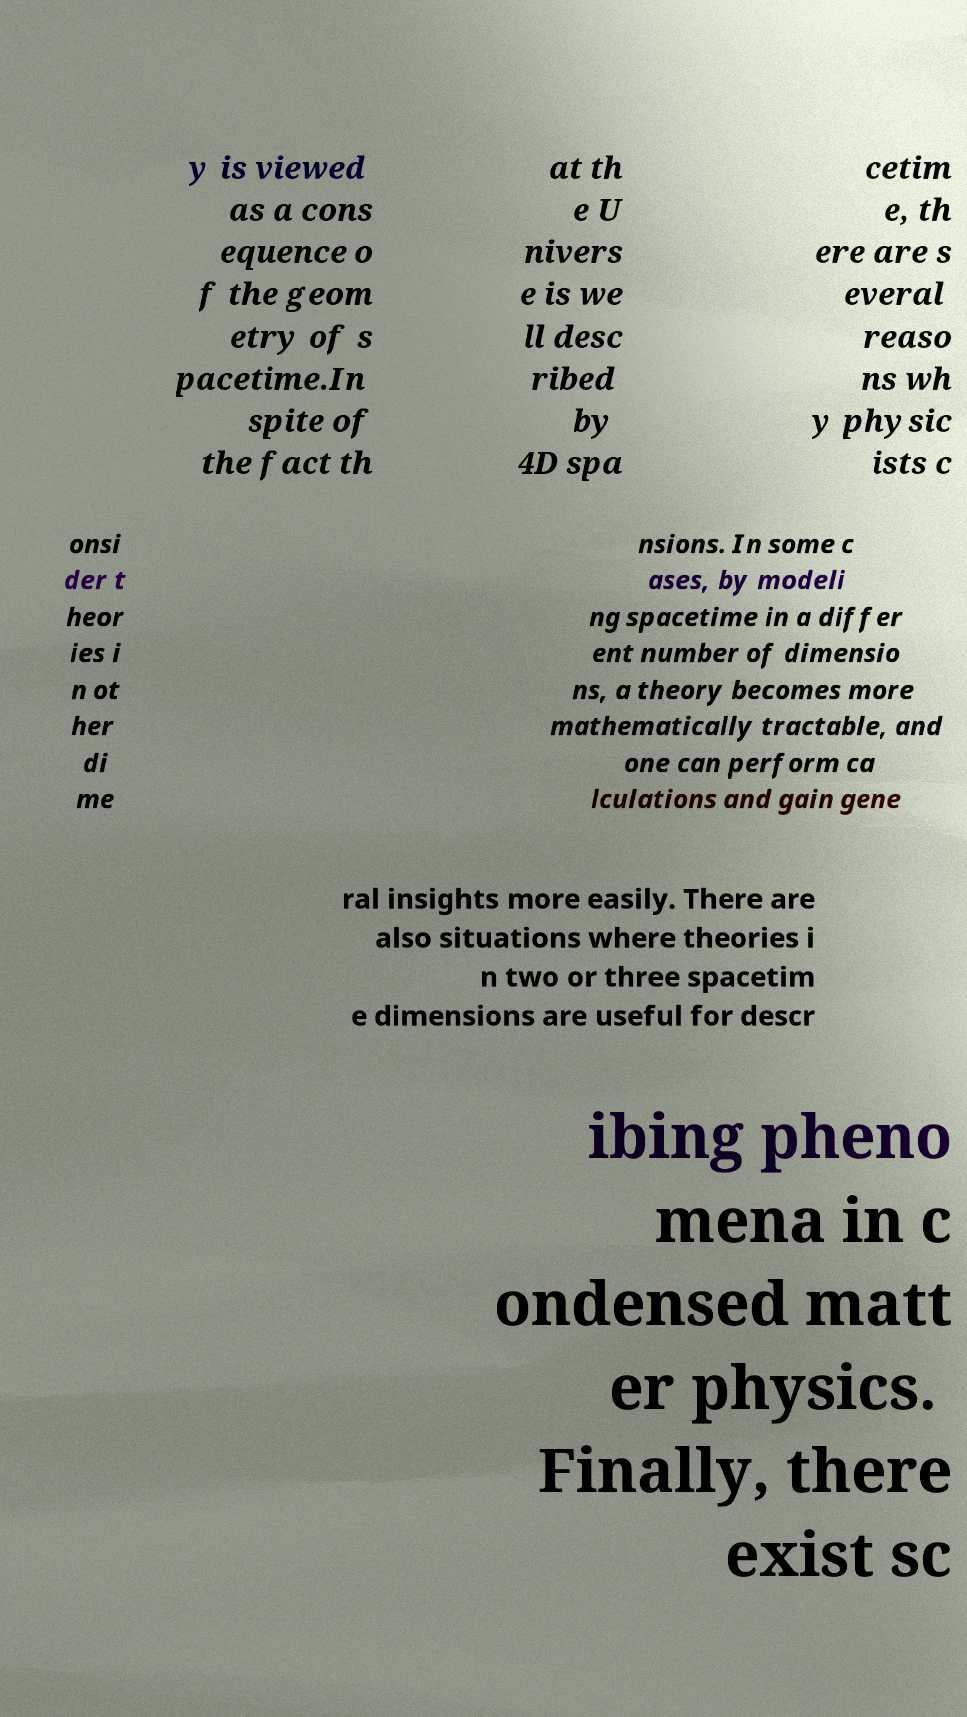Could you extract and type out the text from this image? y is viewed as a cons equence o f the geom etry of s pacetime.In spite of the fact th at th e U nivers e is we ll desc ribed by 4D spa cetim e, th ere are s everal reaso ns wh y physic ists c onsi der t heor ies i n ot her di me nsions. In some c ases, by modeli ng spacetime in a differ ent number of dimensio ns, a theory becomes more mathematically tractable, and one can perform ca lculations and gain gene ral insights more easily. There are also situations where theories i n two or three spacetim e dimensions are useful for descr ibing pheno mena in c ondensed matt er physics. Finally, there exist sc 